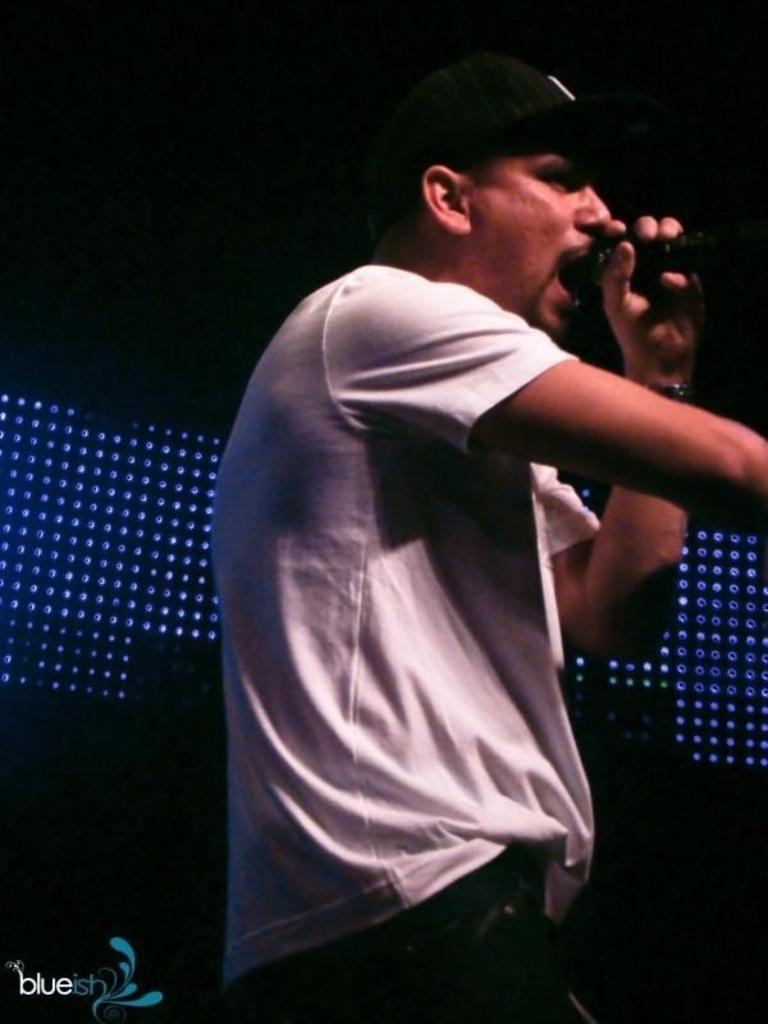How would you summarize this image in a sentence or two? In this picture we can see a man is holding a microphone and singing a song. Behind the man there is a dark background and lights. On the image there is a watermark. 